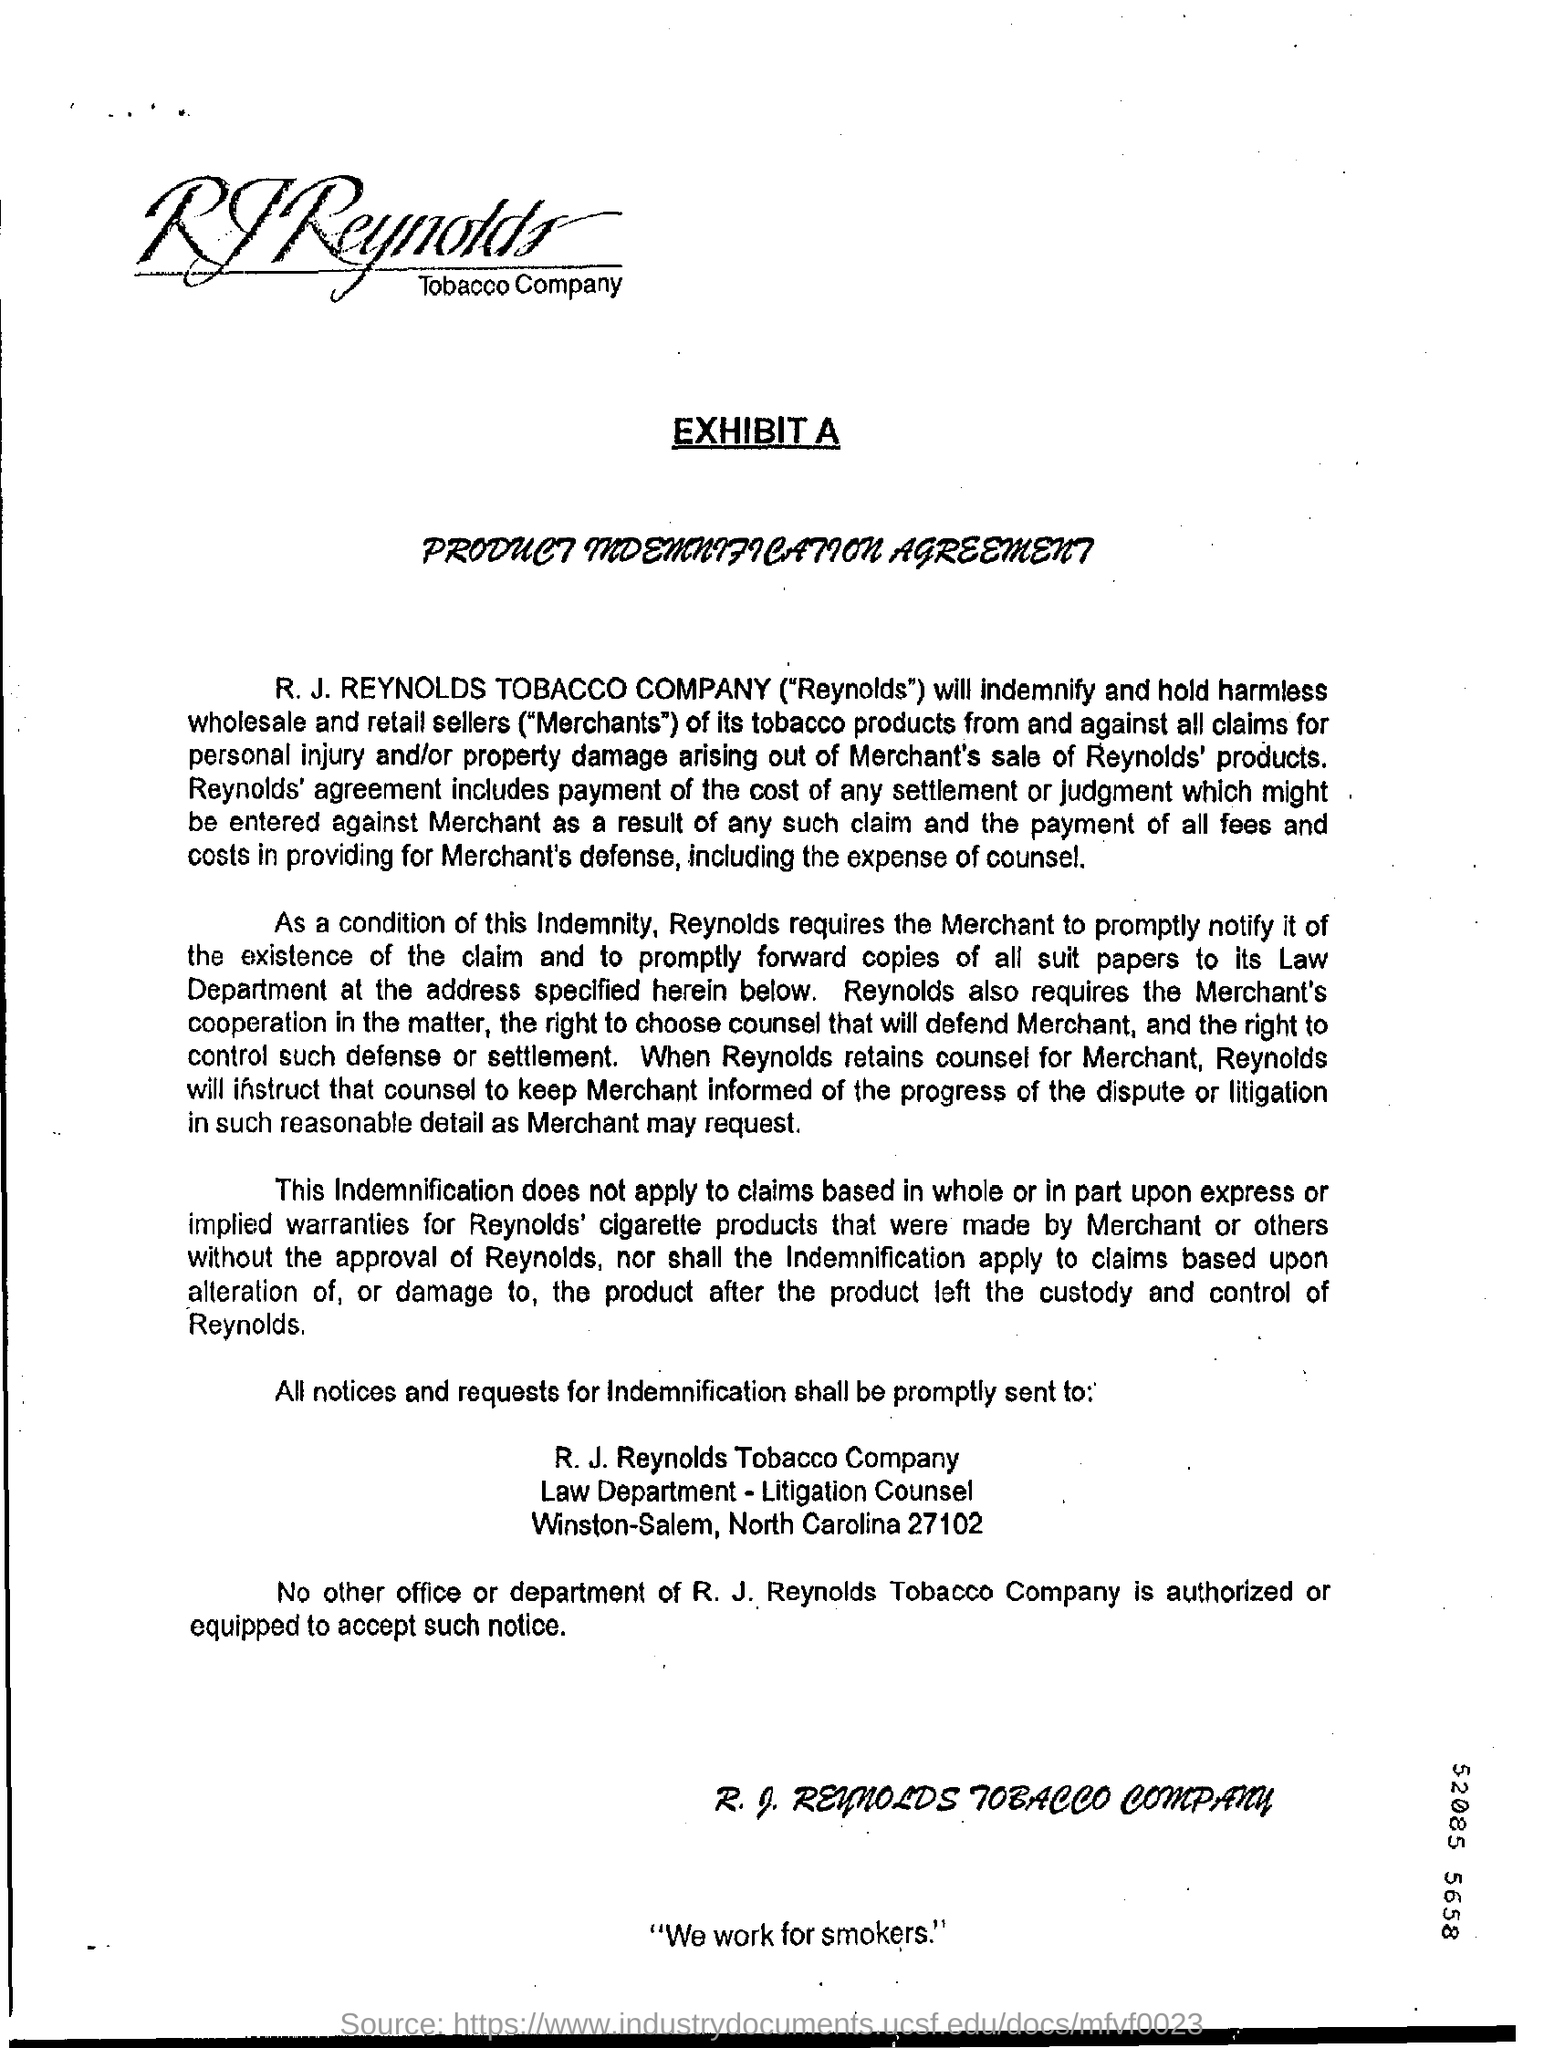Outline some significant characteristics in this image. The slogan at the bottom of the document reads, 'We work for smokers.' I am requesting information about a 9-digit number mentioned as 52085 5658... The sentence written at the end of the page is 'We work for smokers.' 